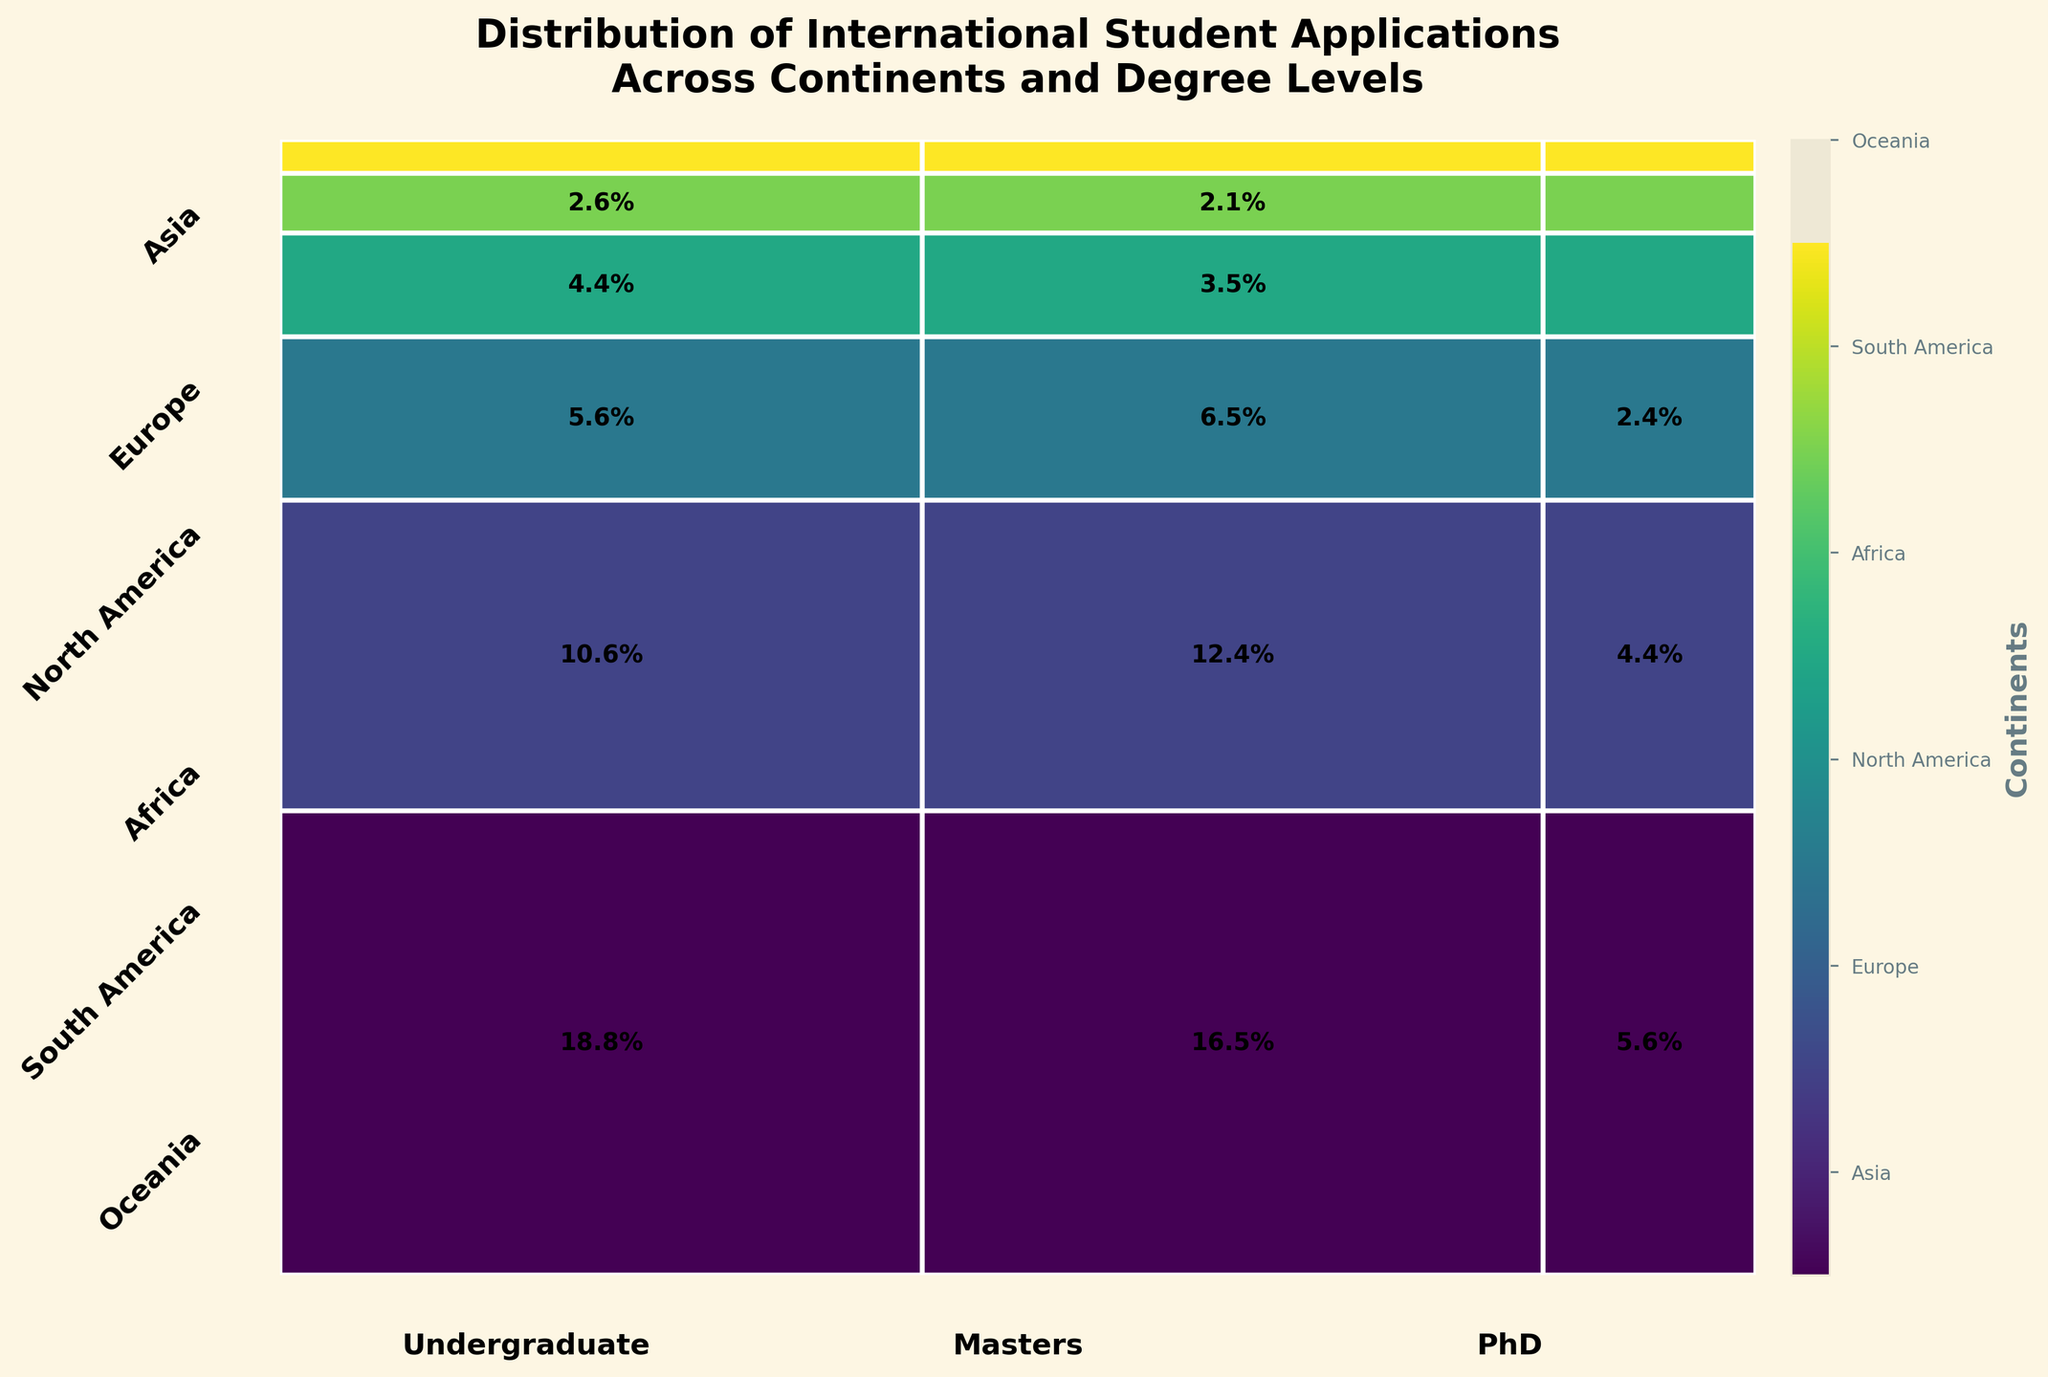What continent has the highest number of international student applications? The largest area in the mosaic plot belongs to Asia, indicating it has the highest number of applications.
Answer: Asia Which degree level has the least number of applications overall? By observing the width of the rectangles for each degree level, PhD has the smallest overall width, indicating it has the least number of applications.
Answer: PhD What is the proportion of undergraduate applications from Europe compared to the total number of applications? Find the resultant area size for Europe-Undergraduate within Europe’s section and divide by the total figure area: 1800 out of 14750 applications, calculated as 1800/14750 ≈ 12.2%.
Answer: ≈ 12.2% Which continent has the smallest number of PhD applications? Find the smallest rectangle among the PhD applications section; Oceania has the smallest rectangle there.
Answer: Oceania Between Asia and North America, which one has more Masters applications? Compare the Masters sections: Asia has a larger area for Masters applications compared to North America.
Answer: Asia What is the total proportion of applications for Masters degrees across all continents? Add up all the fractions corresponding to Masters degree from each continent. They combine into approximately 38.1%.
Answer: ≈ 38.1% Compare the number of Undergraduate applications in Africa to those in Oceania. Which one is greater? Observe the Undergraduate sections for Africa and Oceania: Africa (750 applications) is larger than Oceania (250 applications).
Answer: Africa Which continent represents roughly one-third of the total applications for PhD degree level? Compute: Asia for PhD – 950 out of 2300 PhD applications, calculated as 950/2300 ≈ 41.3%; Europe accounts for roughly 32.6%.
Answer: Europe Across continents, which degree level shows the largest area within the mosaic plot? By comparing the most extensive areas horizontally across different sections, Undergraduate holds the largest.
Answer: Undergraduate What percentage of total applications does Undergraduate study from North America contribute? Find the area proportion of North America-Undergraduate: 950 out of 14750 applications, computed as 950/14750 ≈ 6.4%.
Answer: ≈ 6.4% 